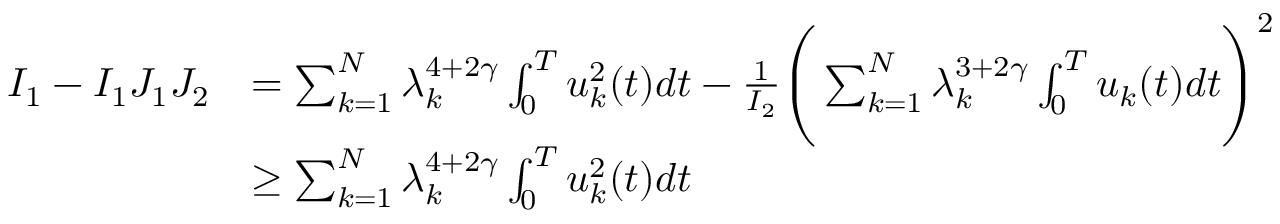<formula> <loc_0><loc_0><loc_500><loc_500>\begin{array} { r l } { I _ { 1 } - I _ { 1 } J _ { 1 } J _ { 2 } } & { = \sum _ { k = 1 } ^ { N } \lambda _ { k } ^ { 4 + 2 \gamma } \int _ { 0 } ^ { T } u _ { k } ^ { 2 } ( t ) d t - \frac { 1 } { I _ { 2 } } \left ( \sum _ { k = 1 } ^ { N } \lambda _ { k } ^ { 3 + 2 \gamma } \int _ { 0 } ^ { T } u _ { k } ( t ) d t \right ) ^ { 2 } } \\ & { \geq \sum _ { k = 1 } ^ { N } \lambda _ { k } ^ { 4 + 2 \gamma } \int _ { 0 } ^ { T } u _ { k } ^ { 2 } ( t ) d t } \end{array}</formula> 